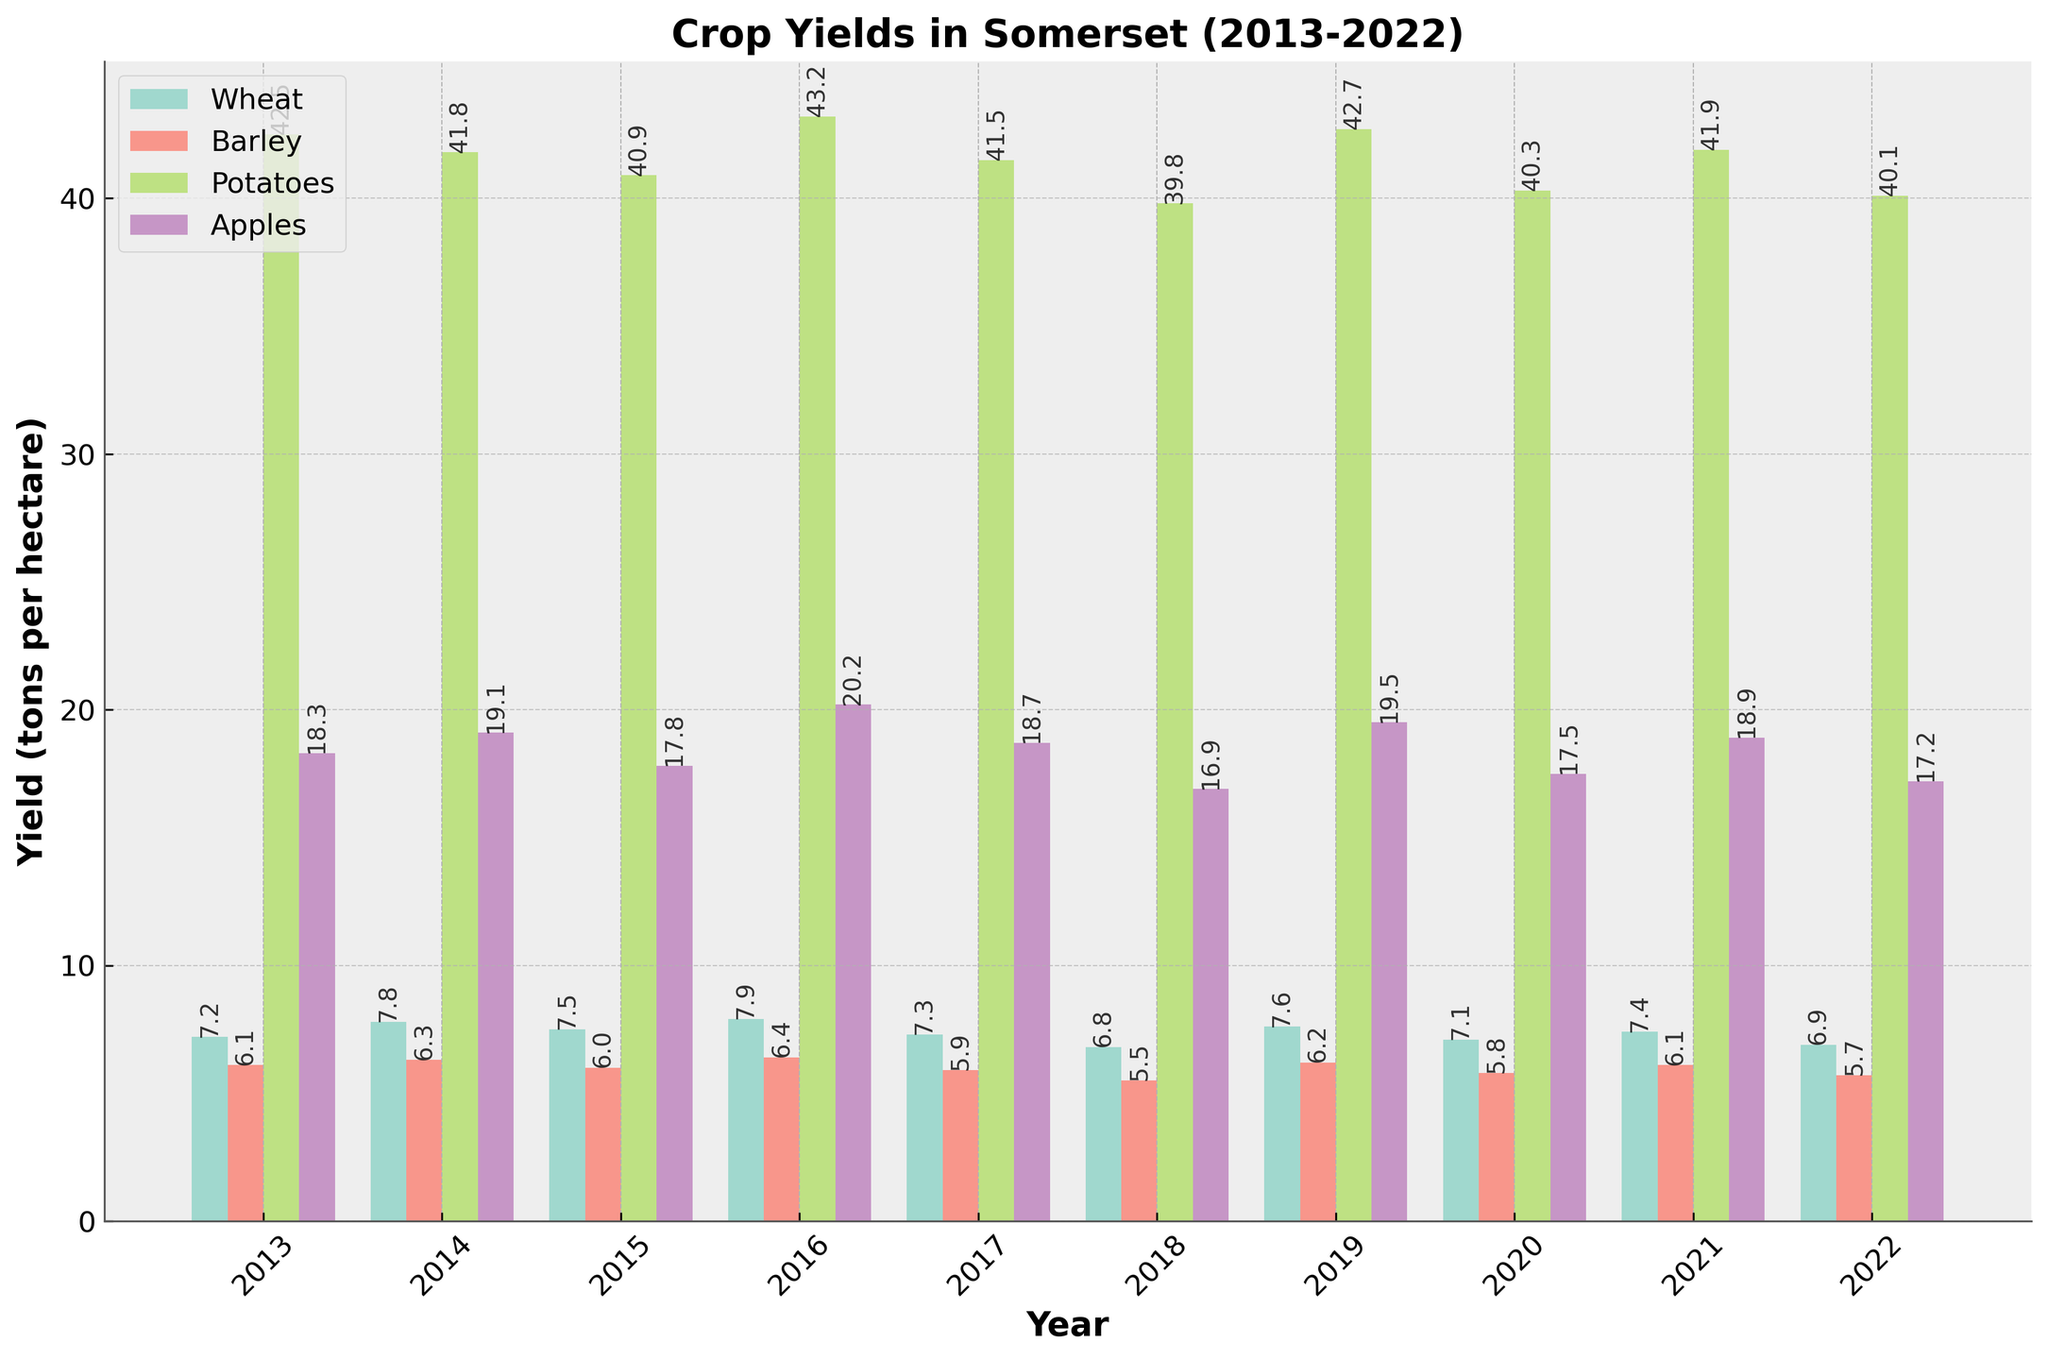Which year had the highest yield for Wheat? To determine the year with the highest wheat yield, look at all the bars representing wheat across different years and identify the tallest bar.
Answer: 2016 What is the total yield of Barley from 2013 to 2015? Add up the Barley yields for the years 2013, 2014, and 2015: 6.1 + 6.3 + 6.0 = 18.4 tons per hectare.
Answer: 18.4 Which crop showed the most consistent yield over the decade? To identify which crop had the most consistent yield, look for the crop whose bars are closest in height across all years. Visual inspection indicates that Barley has relatively consistent yields every year.
Answer: Barley By how much did Milk yield per cow increase from 2013 to 2022? Subtract the Milk yield in 2013 from the yield in 2022: 9060 - 7650 = 1410 litres per cow.
Answer: 1410 Which year had the lowest Apple yield and what was that yield? Identify the shortest bar for Apples across all years, which is in 2018. The yield for 2018 is 16.9 tons per hectare.
Answer: 2018, 16.9 Compare the Potato yield in 2016 with the Potato yield in 2020. Which one is higher? Find the bars for Potato yields in 2016 and 2020. The 2016 yield is 43.2, and the 2020 yield is 40.3. The 2016 yield is higher.
Answer: 2016 What is the average Wheat yield over the decade? Sum up the Wheat yields for each year and divide by the number of years: (7.2 + 7.8 + 7.5 + 7.9 + 7.3 + 6.8 + 7.6 + 7.1 + 7.4 + 6.9) / 10 = 7.25 tons per hectare.
Answer: 7.25 In which year did Barley and Apple yields both see a decline compared to the previous year? Check the bars for Barley and Apples year by year and find the year when both yields are lower than the previous year. This happens in 2018, where both Barley and Apple yields are lower than in 2017.
Answer: 2018 How does the Potato yield in 2019 compare to its average yield over the decade? First, calculate the average Potato yield for the decade: (42.5 + 41.8 + 40.9 + 43.2 + 41.5 + 39.8 + 42.7 + 40.3 + 41.9 + 40.1) / 10 = 41.47 tons per hectare. The yield in 2019 is 42.7, which is higher than the average.
Answer: 42.7, higher What is the trend in Milk yield per cow from 2013 to 2022? Inspect the bar heights for Milk yields over the years. The yield generally increases every year, indicating an upward trend.
Answer: Upward trend 